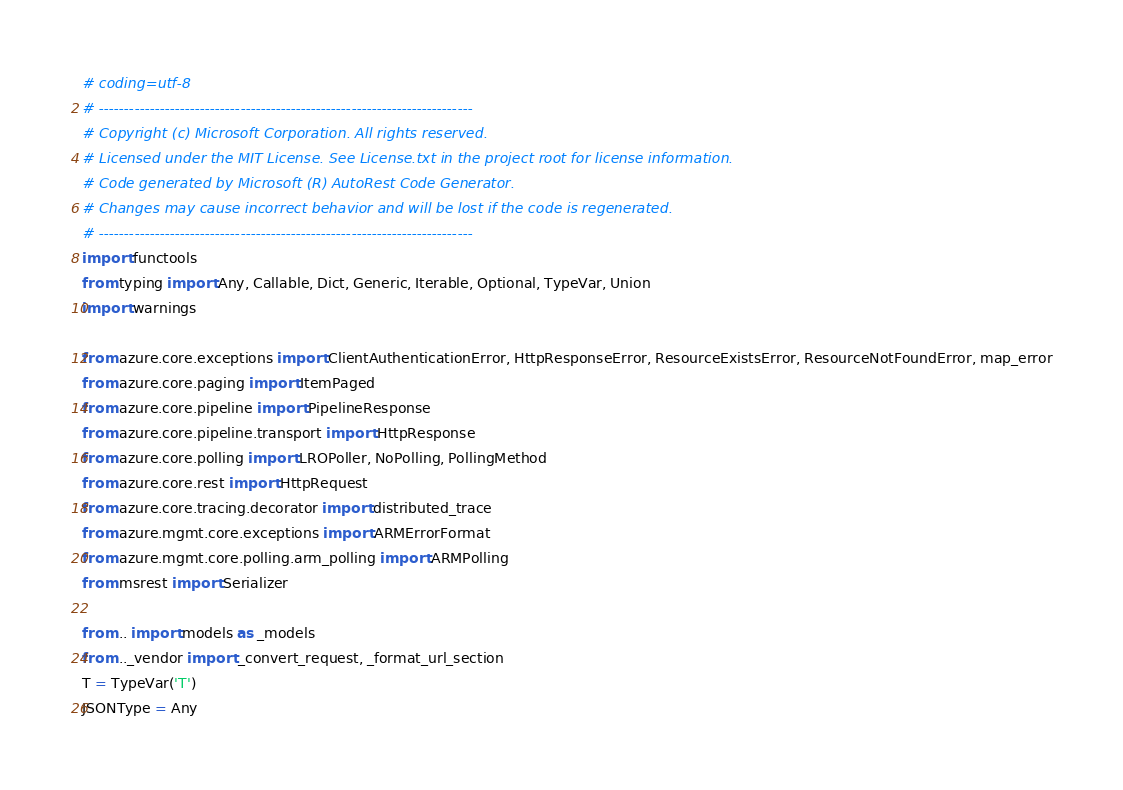Convert code to text. <code><loc_0><loc_0><loc_500><loc_500><_Python_># coding=utf-8
# --------------------------------------------------------------------------
# Copyright (c) Microsoft Corporation. All rights reserved.
# Licensed under the MIT License. See License.txt in the project root for license information.
# Code generated by Microsoft (R) AutoRest Code Generator.
# Changes may cause incorrect behavior and will be lost if the code is regenerated.
# --------------------------------------------------------------------------
import functools
from typing import Any, Callable, Dict, Generic, Iterable, Optional, TypeVar, Union
import warnings

from azure.core.exceptions import ClientAuthenticationError, HttpResponseError, ResourceExistsError, ResourceNotFoundError, map_error
from azure.core.paging import ItemPaged
from azure.core.pipeline import PipelineResponse
from azure.core.pipeline.transport import HttpResponse
from azure.core.polling import LROPoller, NoPolling, PollingMethod
from azure.core.rest import HttpRequest
from azure.core.tracing.decorator import distributed_trace
from azure.mgmt.core.exceptions import ARMErrorFormat
from azure.mgmt.core.polling.arm_polling import ARMPolling
from msrest import Serializer

from .. import models as _models
from .._vendor import _convert_request, _format_url_section
T = TypeVar('T')
JSONType = Any</code> 